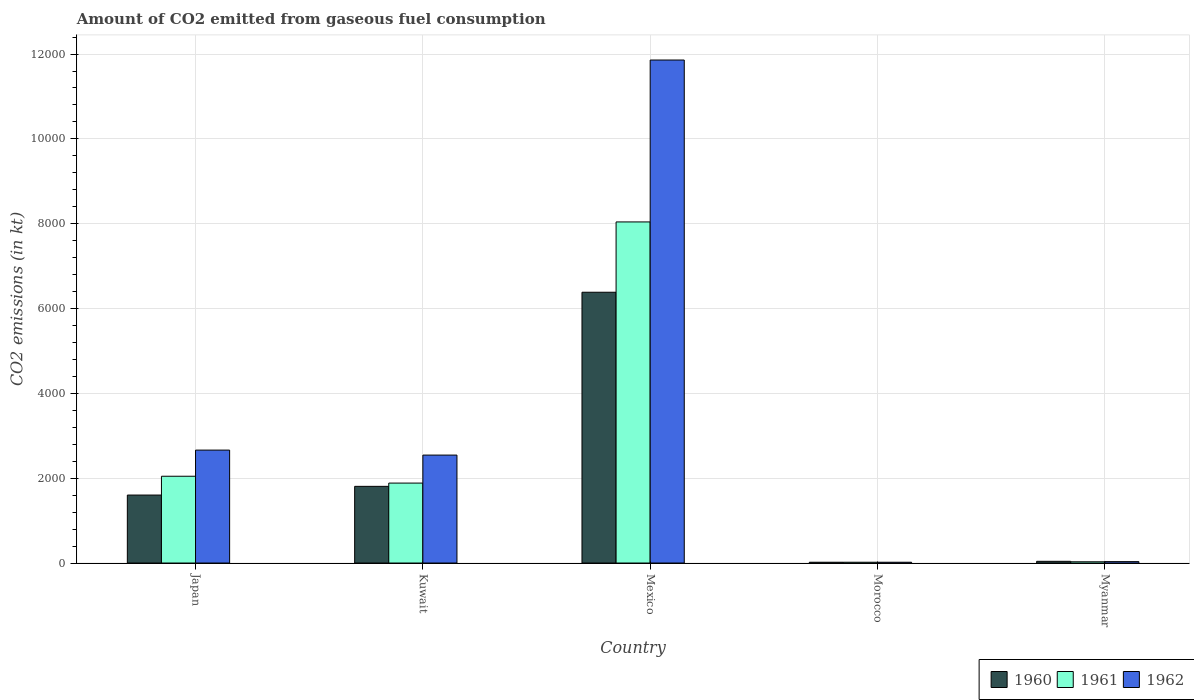How many different coloured bars are there?
Offer a terse response. 3. Are the number of bars per tick equal to the number of legend labels?
Keep it short and to the point. Yes. Are the number of bars on each tick of the X-axis equal?
Offer a very short reply. Yes. How many bars are there on the 4th tick from the right?
Your answer should be very brief. 3. What is the label of the 5th group of bars from the left?
Give a very brief answer. Myanmar. What is the amount of CO2 emitted in 1961 in Myanmar?
Make the answer very short. 29.34. Across all countries, what is the maximum amount of CO2 emitted in 1960?
Keep it short and to the point. 6384.25. Across all countries, what is the minimum amount of CO2 emitted in 1962?
Your response must be concise. 18.34. In which country was the amount of CO2 emitted in 1960 minimum?
Give a very brief answer. Morocco. What is the total amount of CO2 emitted in 1961 in the graph?
Your answer should be very brief. 1.20e+04. What is the difference between the amount of CO2 emitted in 1960 in Japan and that in Morocco?
Make the answer very short. 1584.14. What is the difference between the amount of CO2 emitted in 1960 in Morocco and the amount of CO2 emitted in 1961 in Kuwait?
Provide a succinct answer. -1866.5. What is the average amount of CO2 emitted in 1962 per country?
Make the answer very short. 3423.51. What is the difference between the amount of CO2 emitted of/in 1961 and amount of CO2 emitted of/in 1960 in Mexico?
Offer a very short reply. 1657.48. What is the ratio of the amount of CO2 emitted in 1961 in Kuwait to that in Morocco?
Provide a short and direct response. 102.8. Is the amount of CO2 emitted in 1961 in Japan less than that in Myanmar?
Give a very brief answer. No. Is the difference between the amount of CO2 emitted in 1961 in Japan and Morocco greater than the difference between the amount of CO2 emitted in 1960 in Japan and Morocco?
Offer a terse response. Yes. What is the difference between the highest and the second highest amount of CO2 emitted in 1960?
Give a very brief answer. 4781.77. What is the difference between the highest and the lowest amount of CO2 emitted in 1961?
Ensure brevity in your answer.  8023.4. Is the sum of the amount of CO2 emitted in 1962 in Japan and Kuwait greater than the maximum amount of CO2 emitted in 1960 across all countries?
Offer a terse response. No. What does the 2nd bar from the left in Japan represents?
Your answer should be very brief. 1961. What does the 2nd bar from the right in Myanmar represents?
Ensure brevity in your answer.  1961. Is it the case that in every country, the sum of the amount of CO2 emitted in 1961 and amount of CO2 emitted in 1960 is greater than the amount of CO2 emitted in 1962?
Offer a very short reply. Yes. How many bars are there?
Your answer should be very brief. 15. How many countries are there in the graph?
Your answer should be compact. 5. Are the values on the major ticks of Y-axis written in scientific E-notation?
Keep it short and to the point. No. Does the graph contain grids?
Provide a short and direct response. Yes. How are the legend labels stacked?
Offer a very short reply. Horizontal. What is the title of the graph?
Give a very brief answer. Amount of CO2 emitted from gaseous fuel consumption. Does "1961" appear as one of the legend labels in the graph?
Provide a succinct answer. Yes. What is the label or title of the X-axis?
Offer a terse response. Country. What is the label or title of the Y-axis?
Your response must be concise. CO2 emissions (in kt). What is the CO2 emissions (in kt) of 1960 in Japan?
Give a very brief answer. 1602.48. What is the CO2 emissions (in kt) in 1961 in Japan?
Provide a succinct answer. 2046.19. What is the CO2 emissions (in kt) in 1962 in Japan?
Ensure brevity in your answer.  2662.24. What is the CO2 emissions (in kt) in 1960 in Kuwait?
Keep it short and to the point. 1807.83. What is the CO2 emissions (in kt) of 1961 in Kuwait?
Make the answer very short. 1884.84. What is the CO2 emissions (in kt) of 1962 in Kuwait?
Provide a succinct answer. 2544.9. What is the CO2 emissions (in kt) of 1960 in Mexico?
Give a very brief answer. 6384.25. What is the CO2 emissions (in kt) in 1961 in Mexico?
Offer a very short reply. 8041.73. What is the CO2 emissions (in kt) of 1962 in Mexico?
Make the answer very short. 1.19e+04. What is the CO2 emissions (in kt) of 1960 in Morocco?
Ensure brevity in your answer.  18.34. What is the CO2 emissions (in kt) of 1961 in Morocco?
Provide a short and direct response. 18.34. What is the CO2 emissions (in kt) in 1962 in Morocco?
Offer a terse response. 18.34. What is the CO2 emissions (in kt) of 1960 in Myanmar?
Provide a succinct answer. 40.34. What is the CO2 emissions (in kt) of 1961 in Myanmar?
Make the answer very short. 29.34. What is the CO2 emissions (in kt) of 1962 in Myanmar?
Your answer should be compact. 33. Across all countries, what is the maximum CO2 emissions (in kt) of 1960?
Your response must be concise. 6384.25. Across all countries, what is the maximum CO2 emissions (in kt) in 1961?
Give a very brief answer. 8041.73. Across all countries, what is the maximum CO2 emissions (in kt) in 1962?
Your answer should be compact. 1.19e+04. Across all countries, what is the minimum CO2 emissions (in kt) in 1960?
Your answer should be compact. 18.34. Across all countries, what is the minimum CO2 emissions (in kt) of 1961?
Provide a short and direct response. 18.34. Across all countries, what is the minimum CO2 emissions (in kt) of 1962?
Your answer should be compact. 18.34. What is the total CO2 emissions (in kt) in 1960 in the graph?
Make the answer very short. 9853.23. What is the total CO2 emissions (in kt) of 1961 in the graph?
Give a very brief answer. 1.20e+04. What is the total CO2 emissions (in kt) in 1962 in the graph?
Make the answer very short. 1.71e+04. What is the difference between the CO2 emissions (in kt) of 1960 in Japan and that in Kuwait?
Ensure brevity in your answer.  -205.35. What is the difference between the CO2 emissions (in kt) of 1961 in Japan and that in Kuwait?
Provide a short and direct response. 161.35. What is the difference between the CO2 emissions (in kt) of 1962 in Japan and that in Kuwait?
Give a very brief answer. 117.34. What is the difference between the CO2 emissions (in kt) of 1960 in Japan and that in Mexico?
Your answer should be compact. -4781.77. What is the difference between the CO2 emissions (in kt) of 1961 in Japan and that in Mexico?
Make the answer very short. -5995.55. What is the difference between the CO2 emissions (in kt) in 1962 in Japan and that in Mexico?
Your response must be concise. -9196.84. What is the difference between the CO2 emissions (in kt) of 1960 in Japan and that in Morocco?
Provide a succinct answer. 1584.14. What is the difference between the CO2 emissions (in kt) of 1961 in Japan and that in Morocco?
Your response must be concise. 2027.85. What is the difference between the CO2 emissions (in kt) in 1962 in Japan and that in Morocco?
Ensure brevity in your answer.  2643.91. What is the difference between the CO2 emissions (in kt) in 1960 in Japan and that in Myanmar?
Your answer should be very brief. 1562.14. What is the difference between the CO2 emissions (in kt) in 1961 in Japan and that in Myanmar?
Keep it short and to the point. 2016.85. What is the difference between the CO2 emissions (in kt) of 1962 in Japan and that in Myanmar?
Ensure brevity in your answer.  2629.24. What is the difference between the CO2 emissions (in kt) of 1960 in Kuwait and that in Mexico?
Keep it short and to the point. -4576.42. What is the difference between the CO2 emissions (in kt) in 1961 in Kuwait and that in Mexico?
Keep it short and to the point. -6156.89. What is the difference between the CO2 emissions (in kt) in 1962 in Kuwait and that in Mexico?
Keep it short and to the point. -9314.18. What is the difference between the CO2 emissions (in kt) of 1960 in Kuwait and that in Morocco?
Ensure brevity in your answer.  1789.5. What is the difference between the CO2 emissions (in kt) of 1961 in Kuwait and that in Morocco?
Offer a terse response. 1866.5. What is the difference between the CO2 emissions (in kt) of 1962 in Kuwait and that in Morocco?
Keep it short and to the point. 2526.56. What is the difference between the CO2 emissions (in kt) of 1960 in Kuwait and that in Myanmar?
Offer a terse response. 1767.49. What is the difference between the CO2 emissions (in kt) in 1961 in Kuwait and that in Myanmar?
Give a very brief answer. 1855.5. What is the difference between the CO2 emissions (in kt) in 1962 in Kuwait and that in Myanmar?
Offer a terse response. 2511.89. What is the difference between the CO2 emissions (in kt) in 1960 in Mexico and that in Morocco?
Your response must be concise. 6365.91. What is the difference between the CO2 emissions (in kt) of 1961 in Mexico and that in Morocco?
Your answer should be very brief. 8023.4. What is the difference between the CO2 emissions (in kt) of 1962 in Mexico and that in Morocco?
Your response must be concise. 1.18e+04. What is the difference between the CO2 emissions (in kt) of 1960 in Mexico and that in Myanmar?
Make the answer very short. 6343.91. What is the difference between the CO2 emissions (in kt) of 1961 in Mexico and that in Myanmar?
Provide a short and direct response. 8012.4. What is the difference between the CO2 emissions (in kt) of 1962 in Mexico and that in Myanmar?
Make the answer very short. 1.18e+04. What is the difference between the CO2 emissions (in kt) of 1960 in Morocco and that in Myanmar?
Give a very brief answer. -22. What is the difference between the CO2 emissions (in kt) in 1961 in Morocco and that in Myanmar?
Give a very brief answer. -11. What is the difference between the CO2 emissions (in kt) of 1962 in Morocco and that in Myanmar?
Your answer should be compact. -14.67. What is the difference between the CO2 emissions (in kt) in 1960 in Japan and the CO2 emissions (in kt) in 1961 in Kuwait?
Provide a succinct answer. -282.36. What is the difference between the CO2 emissions (in kt) of 1960 in Japan and the CO2 emissions (in kt) of 1962 in Kuwait?
Ensure brevity in your answer.  -942.42. What is the difference between the CO2 emissions (in kt) in 1961 in Japan and the CO2 emissions (in kt) in 1962 in Kuwait?
Make the answer very short. -498.71. What is the difference between the CO2 emissions (in kt) in 1960 in Japan and the CO2 emissions (in kt) in 1961 in Mexico?
Provide a succinct answer. -6439.25. What is the difference between the CO2 emissions (in kt) in 1960 in Japan and the CO2 emissions (in kt) in 1962 in Mexico?
Your response must be concise. -1.03e+04. What is the difference between the CO2 emissions (in kt) of 1961 in Japan and the CO2 emissions (in kt) of 1962 in Mexico?
Offer a very short reply. -9812.89. What is the difference between the CO2 emissions (in kt) of 1960 in Japan and the CO2 emissions (in kt) of 1961 in Morocco?
Your response must be concise. 1584.14. What is the difference between the CO2 emissions (in kt) in 1960 in Japan and the CO2 emissions (in kt) in 1962 in Morocco?
Your answer should be very brief. 1584.14. What is the difference between the CO2 emissions (in kt) in 1961 in Japan and the CO2 emissions (in kt) in 1962 in Morocco?
Your response must be concise. 2027.85. What is the difference between the CO2 emissions (in kt) of 1960 in Japan and the CO2 emissions (in kt) of 1961 in Myanmar?
Provide a succinct answer. 1573.14. What is the difference between the CO2 emissions (in kt) of 1960 in Japan and the CO2 emissions (in kt) of 1962 in Myanmar?
Keep it short and to the point. 1569.48. What is the difference between the CO2 emissions (in kt) in 1961 in Japan and the CO2 emissions (in kt) in 1962 in Myanmar?
Give a very brief answer. 2013.18. What is the difference between the CO2 emissions (in kt) in 1960 in Kuwait and the CO2 emissions (in kt) in 1961 in Mexico?
Make the answer very short. -6233.9. What is the difference between the CO2 emissions (in kt) of 1960 in Kuwait and the CO2 emissions (in kt) of 1962 in Mexico?
Offer a terse response. -1.01e+04. What is the difference between the CO2 emissions (in kt) in 1961 in Kuwait and the CO2 emissions (in kt) in 1962 in Mexico?
Your response must be concise. -9974.24. What is the difference between the CO2 emissions (in kt) in 1960 in Kuwait and the CO2 emissions (in kt) in 1961 in Morocco?
Your response must be concise. 1789.5. What is the difference between the CO2 emissions (in kt) of 1960 in Kuwait and the CO2 emissions (in kt) of 1962 in Morocco?
Give a very brief answer. 1789.5. What is the difference between the CO2 emissions (in kt) of 1961 in Kuwait and the CO2 emissions (in kt) of 1962 in Morocco?
Provide a succinct answer. 1866.5. What is the difference between the CO2 emissions (in kt) of 1960 in Kuwait and the CO2 emissions (in kt) of 1961 in Myanmar?
Your answer should be very brief. 1778.49. What is the difference between the CO2 emissions (in kt) of 1960 in Kuwait and the CO2 emissions (in kt) of 1962 in Myanmar?
Provide a succinct answer. 1774.83. What is the difference between the CO2 emissions (in kt) of 1961 in Kuwait and the CO2 emissions (in kt) of 1962 in Myanmar?
Ensure brevity in your answer.  1851.84. What is the difference between the CO2 emissions (in kt) in 1960 in Mexico and the CO2 emissions (in kt) in 1961 in Morocco?
Ensure brevity in your answer.  6365.91. What is the difference between the CO2 emissions (in kt) in 1960 in Mexico and the CO2 emissions (in kt) in 1962 in Morocco?
Offer a very short reply. 6365.91. What is the difference between the CO2 emissions (in kt) in 1961 in Mexico and the CO2 emissions (in kt) in 1962 in Morocco?
Ensure brevity in your answer.  8023.4. What is the difference between the CO2 emissions (in kt) of 1960 in Mexico and the CO2 emissions (in kt) of 1961 in Myanmar?
Your response must be concise. 6354.91. What is the difference between the CO2 emissions (in kt) in 1960 in Mexico and the CO2 emissions (in kt) in 1962 in Myanmar?
Your response must be concise. 6351.24. What is the difference between the CO2 emissions (in kt) of 1961 in Mexico and the CO2 emissions (in kt) of 1962 in Myanmar?
Your response must be concise. 8008.73. What is the difference between the CO2 emissions (in kt) of 1960 in Morocco and the CO2 emissions (in kt) of 1961 in Myanmar?
Offer a terse response. -11. What is the difference between the CO2 emissions (in kt) in 1960 in Morocco and the CO2 emissions (in kt) in 1962 in Myanmar?
Offer a terse response. -14.67. What is the difference between the CO2 emissions (in kt) in 1961 in Morocco and the CO2 emissions (in kt) in 1962 in Myanmar?
Your answer should be very brief. -14.67. What is the average CO2 emissions (in kt) of 1960 per country?
Your answer should be very brief. 1970.65. What is the average CO2 emissions (in kt) in 1961 per country?
Provide a succinct answer. 2404.09. What is the average CO2 emissions (in kt) of 1962 per country?
Your response must be concise. 3423.51. What is the difference between the CO2 emissions (in kt) in 1960 and CO2 emissions (in kt) in 1961 in Japan?
Offer a terse response. -443.71. What is the difference between the CO2 emissions (in kt) in 1960 and CO2 emissions (in kt) in 1962 in Japan?
Give a very brief answer. -1059.76. What is the difference between the CO2 emissions (in kt) in 1961 and CO2 emissions (in kt) in 1962 in Japan?
Provide a succinct answer. -616.06. What is the difference between the CO2 emissions (in kt) in 1960 and CO2 emissions (in kt) in 1961 in Kuwait?
Your answer should be very brief. -77.01. What is the difference between the CO2 emissions (in kt) in 1960 and CO2 emissions (in kt) in 1962 in Kuwait?
Your response must be concise. -737.07. What is the difference between the CO2 emissions (in kt) of 1961 and CO2 emissions (in kt) of 1962 in Kuwait?
Provide a short and direct response. -660.06. What is the difference between the CO2 emissions (in kt) of 1960 and CO2 emissions (in kt) of 1961 in Mexico?
Your answer should be compact. -1657.48. What is the difference between the CO2 emissions (in kt) in 1960 and CO2 emissions (in kt) in 1962 in Mexico?
Provide a succinct answer. -5474.83. What is the difference between the CO2 emissions (in kt) of 1961 and CO2 emissions (in kt) of 1962 in Mexico?
Offer a terse response. -3817.35. What is the difference between the CO2 emissions (in kt) in 1960 and CO2 emissions (in kt) in 1961 in Morocco?
Give a very brief answer. 0. What is the difference between the CO2 emissions (in kt) of 1960 and CO2 emissions (in kt) of 1962 in Morocco?
Offer a terse response. 0. What is the difference between the CO2 emissions (in kt) in 1961 and CO2 emissions (in kt) in 1962 in Morocco?
Provide a short and direct response. 0. What is the difference between the CO2 emissions (in kt) of 1960 and CO2 emissions (in kt) of 1961 in Myanmar?
Offer a very short reply. 11. What is the difference between the CO2 emissions (in kt) of 1960 and CO2 emissions (in kt) of 1962 in Myanmar?
Offer a terse response. 7.33. What is the difference between the CO2 emissions (in kt) of 1961 and CO2 emissions (in kt) of 1962 in Myanmar?
Offer a terse response. -3.67. What is the ratio of the CO2 emissions (in kt) in 1960 in Japan to that in Kuwait?
Provide a succinct answer. 0.89. What is the ratio of the CO2 emissions (in kt) in 1961 in Japan to that in Kuwait?
Ensure brevity in your answer.  1.09. What is the ratio of the CO2 emissions (in kt) of 1962 in Japan to that in Kuwait?
Keep it short and to the point. 1.05. What is the ratio of the CO2 emissions (in kt) of 1960 in Japan to that in Mexico?
Ensure brevity in your answer.  0.25. What is the ratio of the CO2 emissions (in kt) in 1961 in Japan to that in Mexico?
Provide a short and direct response. 0.25. What is the ratio of the CO2 emissions (in kt) in 1962 in Japan to that in Mexico?
Ensure brevity in your answer.  0.22. What is the ratio of the CO2 emissions (in kt) in 1960 in Japan to that in Morocco?
Your response must be concise. 87.4. What is the ratio of the CO2 emissions (in kt) in 1961 in Japan to that in Morocco?
Make the answer very short. 111.6. What is the ratio of the CO2 emissions (in kt) in 1962 in Japan to that in Morocco?
Give a very brief answer. 145.2. What is the ratio of the CO2 emissions (in kt) of 1960 in Japan to that in Myanmar?
Provide a succinct answer. 39.73. What is the ratio of the CO2 emissions (in kt) in 1961 in Japan to that in Myanmar?
Ensure brevity in your answer.  69.75. What is the ratio of the CO2 emissions (in kt) in 1962 in Japan to that in Myanmar?
Keep it short and to the point. 80.67. What is the ratio of the CO2 emissions (in kt) of 1960 in Kuwait to that in Mexico?
Your answer should be very brief. 0.28. What is the ratio of the CO2 emissions (in kt) of 1961 in Kuwait to that in Mexico?
Your answer should be very brief. 0.23. What is the ratio of the CO2 emissions (in kt) in 1962 in Kuwait to that in Mexico?
Your answer should be very brief. 0.21. What is the ratio of the CO2 emissions (in kt) in 1960 in Kuwait to that in Morocco?
Your answer should be compact. 98.6. What is the ratio of the CO2 emissions (in kt) in 1961 in Kuwait to that in Morocco?
Ensure brevity in your answer.  102.8. What is the ratio of the CO2 emissions (in kt) of 1962 in Kuwait to that in Morocco?
Your answer should be very brief. 138.8. What is the ratio of the CO2 emissions (in kt) in 1960 in Kuwait to that in Myanmar?
Provide a short and direct response. 44.82. What is the ratio of the CO2 emissions (in kt) in 1961 in Kuwait to that in Myanmar?
Your answer should be very brief. 64.25. What is the ratio of the CO2 emissions (in kt) of 1962 in Kuwait to that in Myanmar?
Ensure brevity in your answer.  77.11. What is the ratio of the CO2 emissions (in kt) of 1960 in Mexico to that in Morocco?
Ensure brevity in your answer.  348.2. What is the ratio of the CO2 emissions (in kt) in 1961 in Mexico to that in Morocco?
Give a very brief answer. 438.6. What is the ratio of the CO2 emissions (in kt) of 1962 in Mexico to that in Morocco?
Provide a succinct answer. 646.8. What is the ratio of the CO2 emissions (in kt) of 1960 in Mexico to that in Myanmar?
Your response must be concise. 158.27. What is the ratio of the CO2 emissions (in kt) of 1961 in Mexico to that in Myanmar?
Provide a succinct answer. 274.12. What is the ratio of the CO2 emissions (in kt) of 1962 in Mexico to that in Myanmar?
Keep it short and to the point. 359.33. What is the ratio of the CO2 emissions (in kt) in 1960 in Morocco to that in Myanmar?
Make the answer very short. 0.45. What is the ratio of the CO2 emissions (in kt) in 1962 in Morocco to that in Myanmar?
Ensure brevity in your answer.  0.56. What is the difference between the highest and the second highest CO2 emissions (in kt) in 1960?
Ensure brevity in your answer.  4576.42. What is the difference between the highest and the second highest CO2 emissions (in kt) of 1961?
Your answer should be very brief. 5995.55. What is the difference between the highest and the second highest CO2 emissions (in kt) in 1962?
Your answer should be compact. 9196.84. What is the difference between the highest and the lowest CO2 emissions (in kt) in 1960?
Provide a short and direct response. 6365.91. What is the difference between the highest and the lowest CO2 emissions (in kt) of 1961?
Offer a very short reply. 8023.4. What is the difference between the highest and the lowest CO2 emissions (in kt) in 1962?
Ensure brevity in your answer.  1.18e+04. 